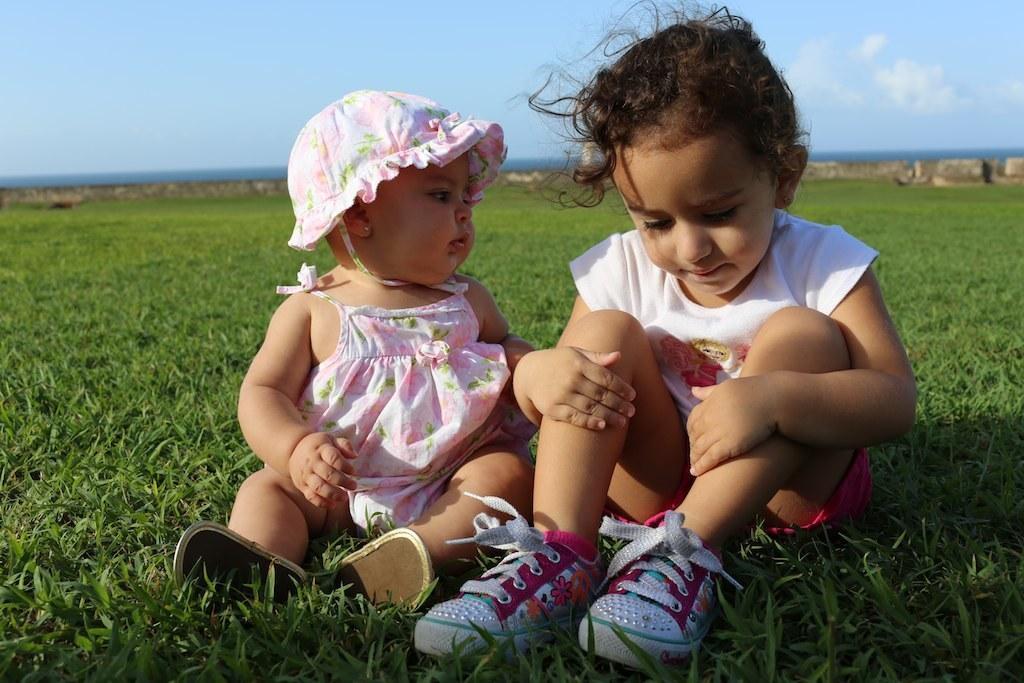In one or two sentences, can you explain what this image depicts? In this image there are two kids sitting on the ground. At the bottom there is grass. At the top there is the sky. In the middle there is a wall in the background. 